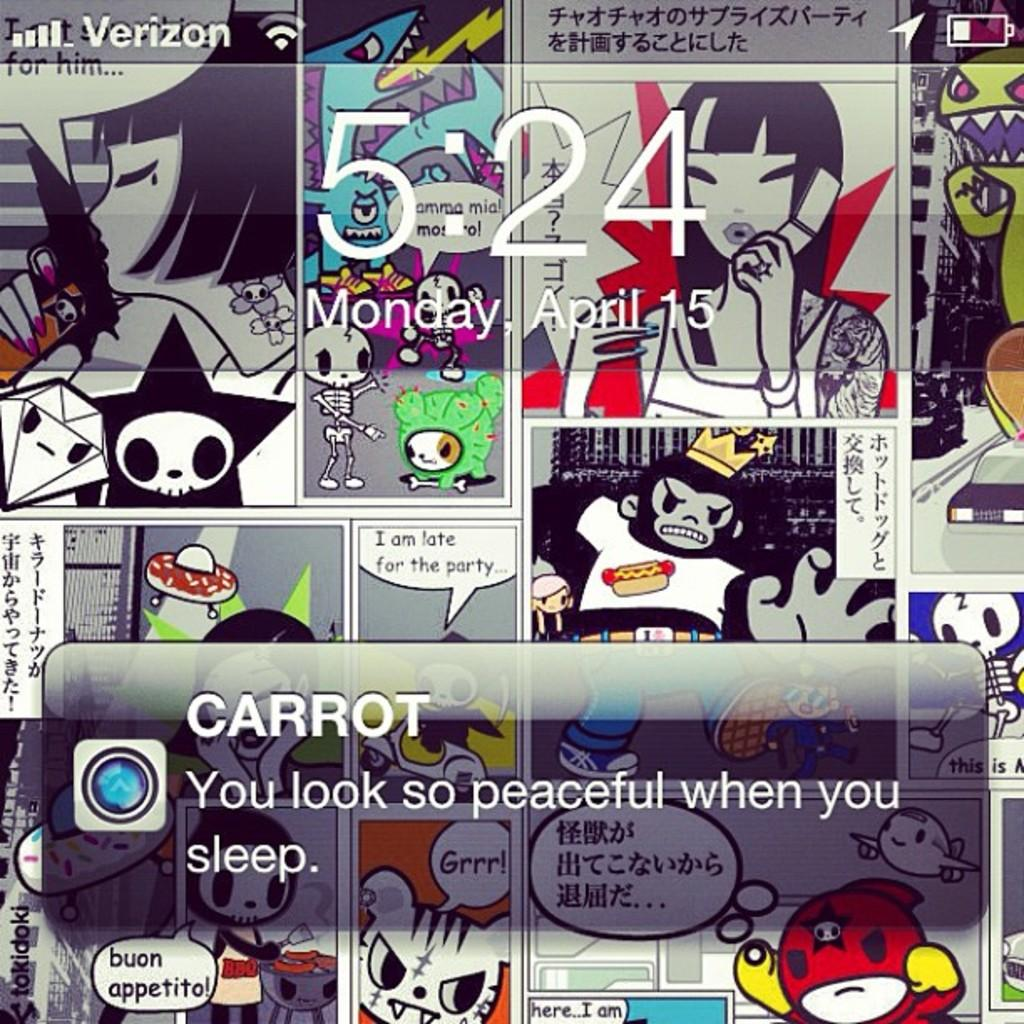What is the primary medium of the image? The image is a screen. What color are the texts on the screen? The texts on the screen are white. What type of images can be seen on the screen? There are cartoon images on the screen. What type of tin can be seen in the image? There is no tin present in the image; it only contains white texts and cartoon images on a screen. 